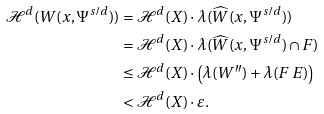<formula> <loc_0><loc_0><loc_500><loc_500>\mathcal { H } ^ { d } ( W ( x , \Psi ^ { s / d } ) ) & = \mathcal { H } ^ { d } ( X ) \cdot \lambda ( \widehat { W } ( x , \Psi ^ { s / d } ) ) \\ & = \mathcal { H } ^ { d } ( X ) \cdot \lambda ( \widehat { W } ( x , \Psi ^ { s / d } ) \cap F ) \\ & \leq \mathcal { H } ^ { d } ( X ) \cdot \left ( \lambda ( W ^ { \prime \prime } ) + \lambda ( F \ E ) \right ) \\ & < \mathcal { H } ^ { d } ( X ) \cdot \varepsilon .</formula> 